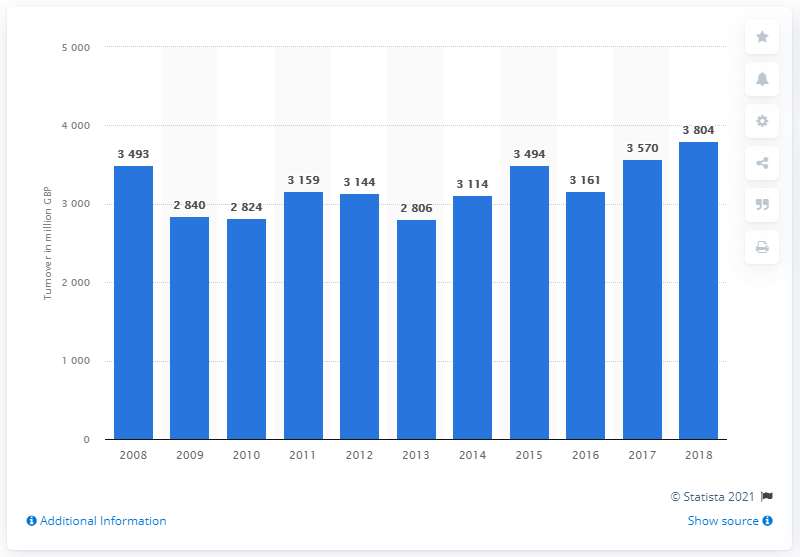Give some essential details in this illustration. In 2018, the retail sale of carpets in the UK reached its peak turnover of 3804 units. The turnover of carpet retail sales in 2013 was 2806. 